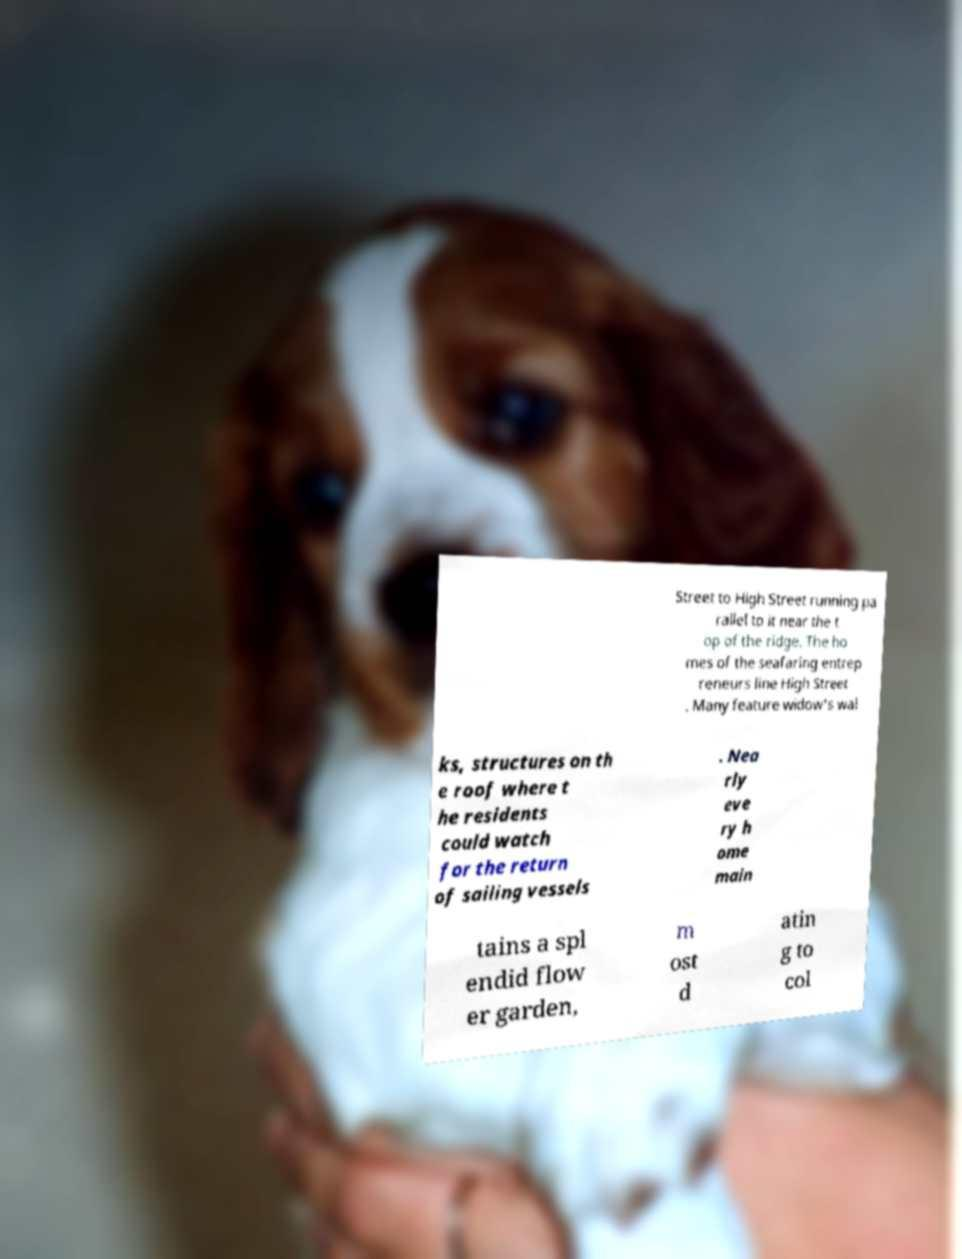I need the written content from this picture converted into text. Can you do that? Street to High Street running pa rallel to it near the t op of the ridge. The ho mes of the seafaring entrep reneurs line High Street . Many feature widow's wal ks, structures on th e roof where t he residents could watch for the return of sailing vessels . Nea rly eve ry h ome main tains a spl endid flow er garden, m ost d atin g to col 